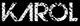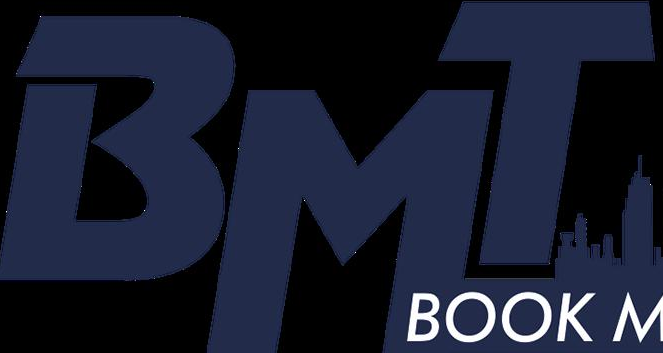What text is displayed in these images sequentially, separated by a semicolon? KΛROL; BMT 